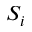<formula> <loc_0><loc_0><loc_500><loc_500>S _ { i }</formula> 